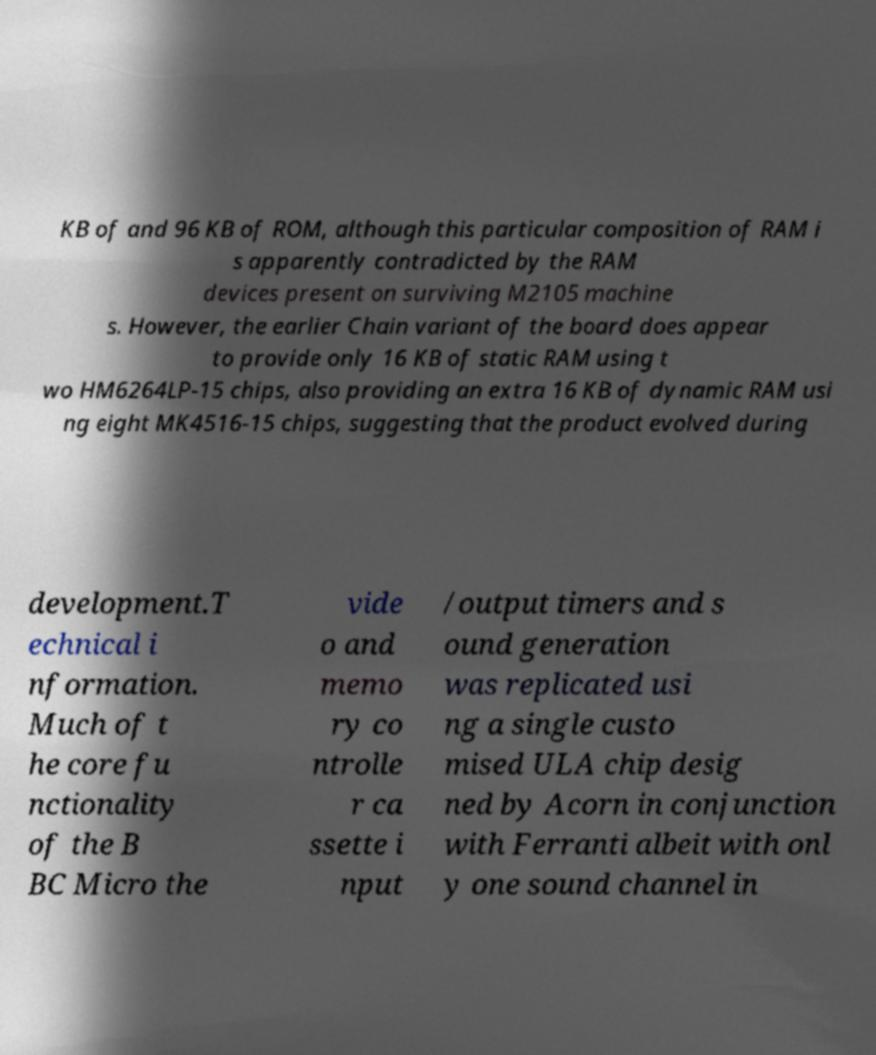For documentation purposes, I need the text within this image transcribed. Could you provide that? KB of and 96 KB of ROM, although this particular composition of RAM i s apparently contradicted by the RAM devices present on surviving M2105 machine s. However, the earlier Chain variant of the board does appear to provide only 16 KB of static RAM using t wo HM6264LP-15 chips, also providing an extra 16 KB of dynamic RAM usi ng eight MK4516-15 chips, suggesting that the product evolved during development.T echnical i nformation. Much of t he core fu nctionality of the B BC Micro the vide o and memo ry co ntrolle r ca ssette i nput /output timers and s ound generation was replicated usi ng a single custo mised ULA chip desig ned by Acorn in conjunction with Ferranti albeit with onl y one sound channel in 